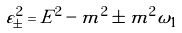<formula> <loc_0><loc_0><loc_500><loc_500>\varepsilon _ { \pm } ^ { 2 } = E ^ { 2 } - m ^ { 2 } \pm m ^ { 2 } \omega _ { 1 }</formula> 